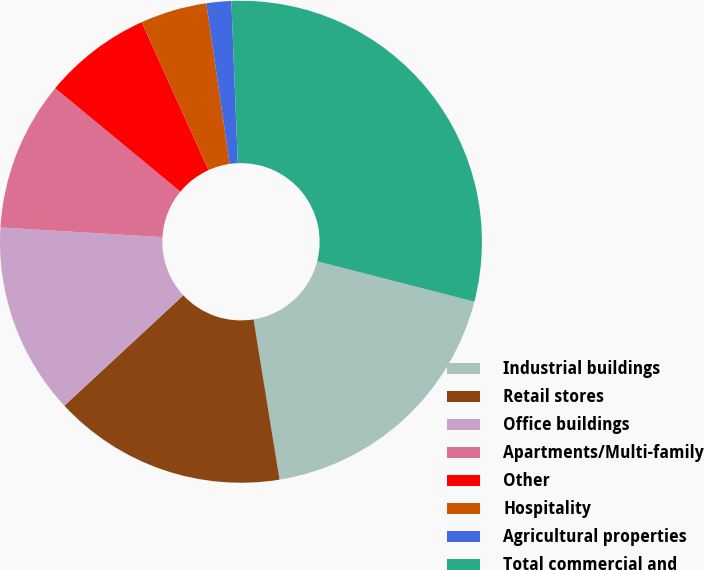<chart> <loc_0><loc_0><loc_500><loc_500><pie_chart><fcel>Industrial buildings<fcel>Retail stores<fcel>Office buildings<fcel>Apartments/Multi-family<fcel>Other<fcel>Hospitality<fcel>Agricultural properties<fcel>Total commercial and<nl><fcel>18.44%<fcel>15.65%<fcel>12.85%<fcel>10.05%<fcel>7.25%<fcel>4.46%<fcel>1.66%<fcel>29.63%<nl></chart> 